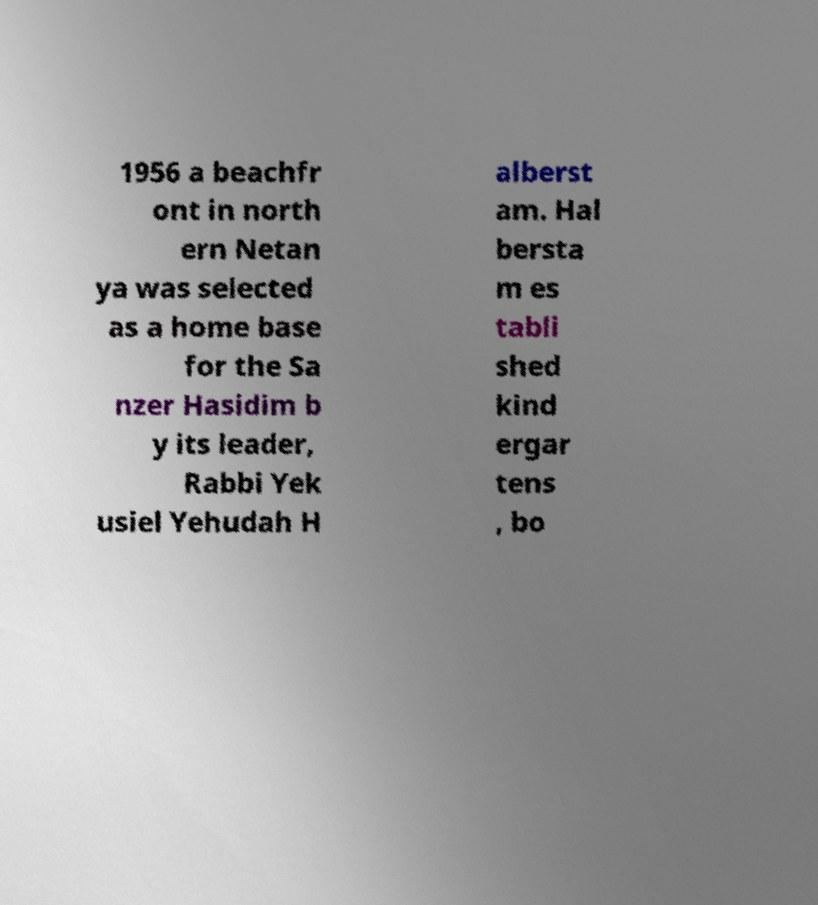Could you assist in decoding the text presented in this image and type it out clearly? 1956 a beachfr ont in north ern Netan ya was selected as a home base for the Sa nzer Hasidim b y its leader, Rabbi Yek usiel Yehudah H alberst am. Hal bersta m es tabli shed kind ergar tens , bo 